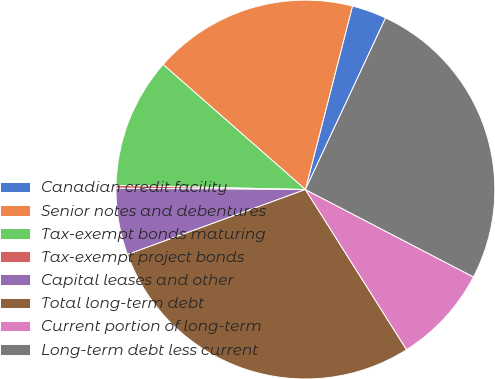Convert chart to OTSL. <chart><loc_0><loc_0><loc_500><loc_500><pie_chart><fcel>Canadian credit facility<fcel>Senior notes and debentures<fcel>Tax-exempt bonds maturing<fcel>Tax-exempt project bonds<fcel>Capital leases and other<fcel>Total long-term debt<fcel>Current portion of long-term<fcel>Long-term debt less current<nl><fcel>2.96%<fcel>17.52%<fcel>11.12%<fcel>0.24%<fcel>5.68%<fcel>28.39%<fcel>8.4%<fcel>25.67%<nl></chart> 